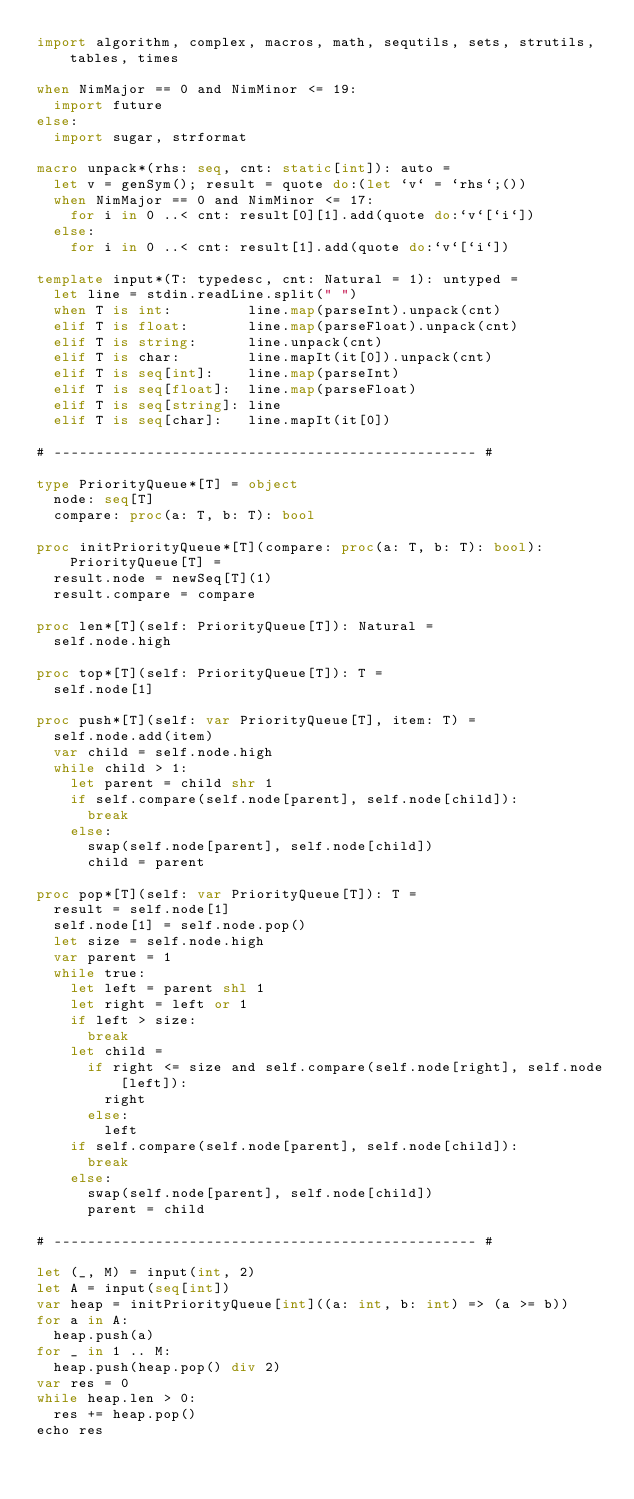<code> <loc_0><loc_0><loc_500><loc_500><_Nim_>import algorithm, complex, macros, math, sequtils, sets, strutils, tables, times

when NimMajor == 0 and NimMinor <= 19:
  import future
else:
  import sugar, strformat

macro unpack*(rhs: seq, cnt: static[int]): auto =
  let v = genSym(); result = quote do:(let `v` = `rhs`;())
  when NimMajor == 0 and NimMinor <= 17:
    for i in 0 ..< cnt: result[0][1].add(quote do:`v`[`i`])
  else:
    for i in 0 ..< cnt: result[1].add(quote do:`v`[`i`])

template input*(T: typedesc, cnt: Natural = 1): untyped =
  let line = stdin.readLine.split(" ")
  when T is int:         line.map(parseInt).unpack(cnt)
  elif T is float:       line.map(parseFloat).unpack(cnt)
  elif T is string:      line.unpack(cnt)
  elif T is char:        line.mapIt(it[0]).unpack(cnt)
  elif T is seq[int]:    line.map(parseInt)
  elif T is seq[float]:  line.map(parseFloat)
  elif T is seq[string]: line
  elif T is seq[char]:   line.mapIt(it[0])

# -------------------------------------------------- #

type PriorityQueue*[T] = object
  node: seq[T]
  compare: proc(a: T, b: T): bool

proc initPriorityQueue*[T](compare: proc(a: T, b: T): bool): PriorityQueue[T] =
  result.node = newSeq[T](1)
  result.compare = compare

proc len*[T](self: PriorityQueue[T]): Natural =
  self.node.high

proc top*[T](self: PriorityQueue[T]): T =
  self.node[1]

proc push*[T](self: var PriorityQueue[T], item: T) =
  self.node.add(item)
  var child = self.node.high
  while child > 1:
    let parent = child shr 1
    if self.compare(self.node[parent], self.node[child]):
      break
    else:
      swap(self.node[parent], self.node[child])
      child = parent

proc pop*[T](self: var PriorityQueue[T]): T =
  result = self.node[1]
  self.node[1] = self.node.pop()
  let size = self.node.high
  var parent = 1
  while true:
    let left = parent shl 1
    let right = left or 1
    if left > size:
      break
    let child =
      if right <= size and self.compare(self.node[right], self.node[left]):
        right
      else:
        left
    if self.compare(self.node[parent], self.node[child]):
      break
    else:
      swap(self.node[parent], self.node[child])
      parent = child

# -------------------------------------------------- #

let (_, M) = input(int, 2)
let A = input(seq[int])
var heap = initPriorityQueue[int]((a: int, b: int) => (a >= b))
for a in A:
  heap.push(a)
for _ in 1 .. M:
  heap.push(heap.pop() div 2)
var res = 0
while heap.len > 0:
  res += heap.pop()
echo res</code> 